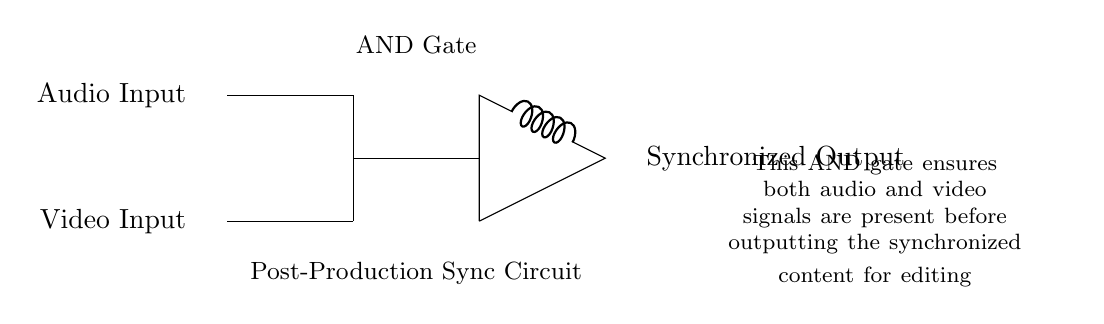What are the inputs to the circuit? The inputs to the circuit are labeled as "Audio Input" and "Video Input" on the left side of the diagram. The labels indicate the signals fed into the AND gate for synchronization.
Answer: Audio Input, Video Input What type of logic gate is used in this circuit? The circuit specifically denotes an "AND Gate" in the middle section, which is essential for circuit operations that require both inputs to be present for the output.
Answer: AND Gate What does the output represent? The output labeled "Synchronized Output" indicates that the circuit's function is to provide an output signal that has synchronized audio and video, contingent on both inputs being active.
Answer: Synchronized Output How many inputs does the AND gate have? The diagram shows two inputs entering the AND gate, which is characteristic of this type of gate, confirming that both audio and video inputs must be present for the output.
Answer: Two What is the purpose of the AND gate in this circuit? The AND gate combines the audio and video signals by ensuring both are present before producing the synchronized output, as stated in the explanatory text accompanying the circuit.
Answer: Synchronization What does the circuit indicate if one input is missing? If either the audio or video input is missing, the AND gate will not produce the synchronized output, highlighting its role in requiring both signals for functionality.
Answer: No output 